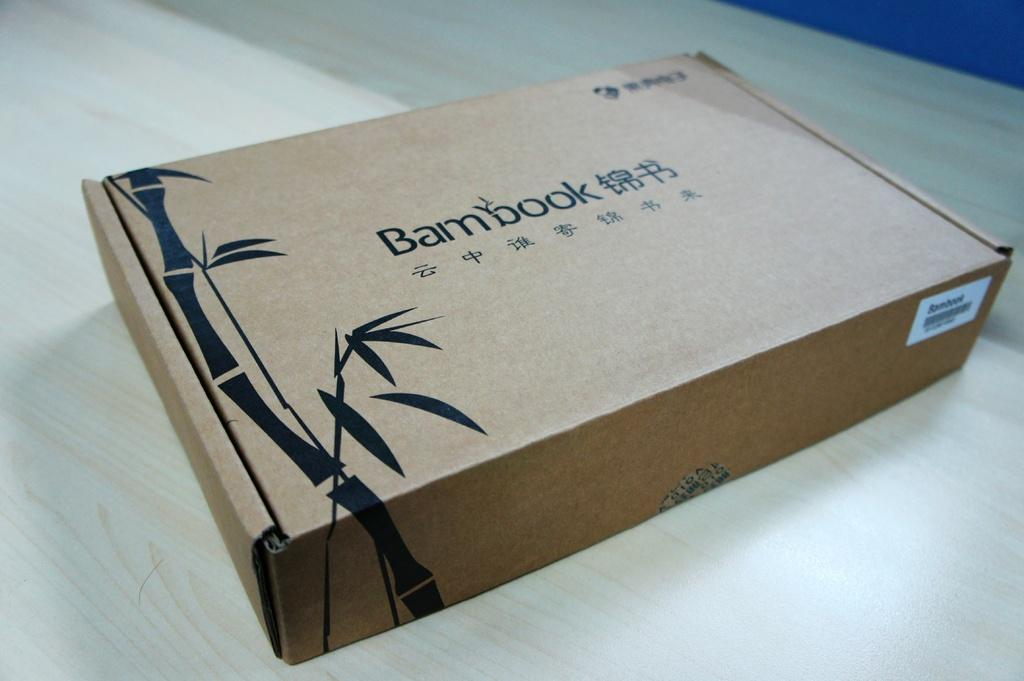<image>
Render a clear and concise summary of the photo. A box with a picture of bamboo on it is labeled Bambook. 